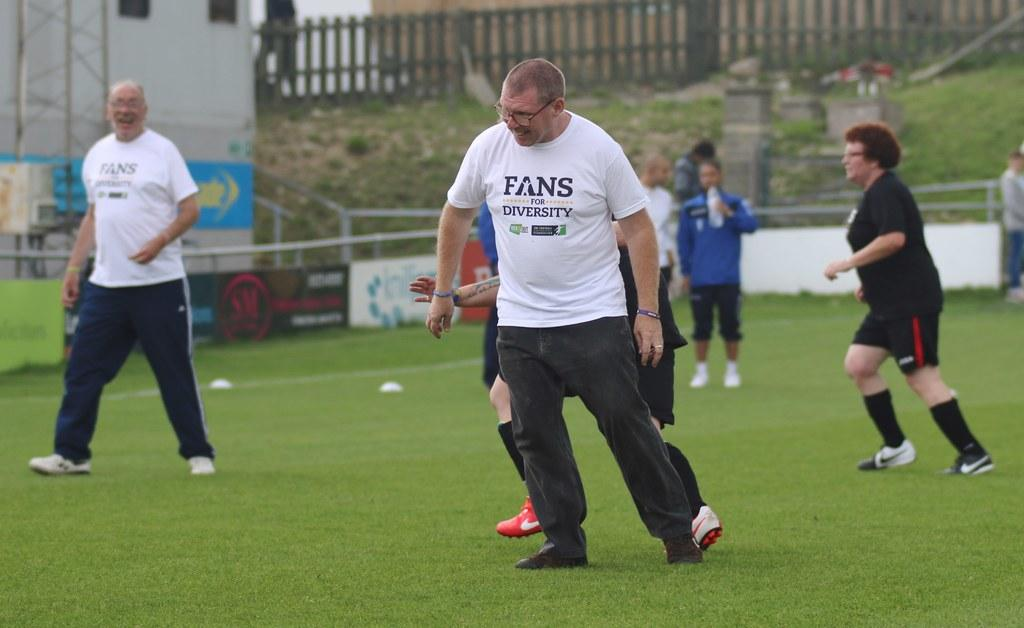Provide a one-sentence caption for the provided image. A man on a sports field wears a shirt that says "Fans for Diversity". 